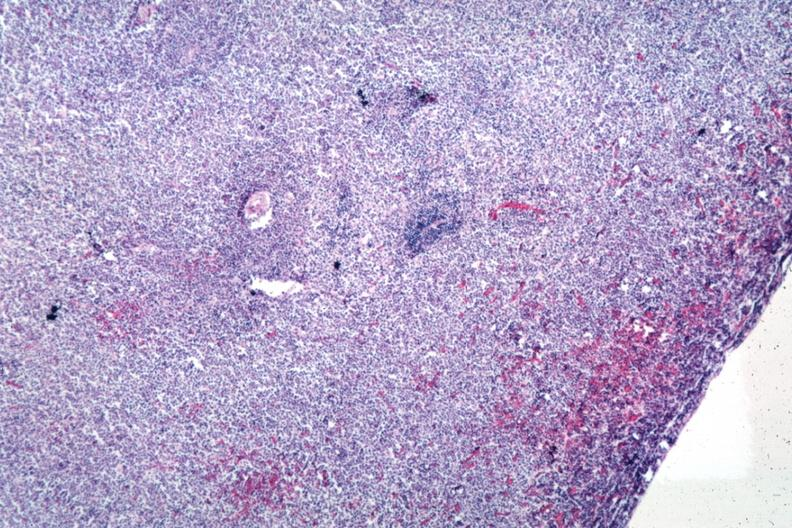what is present?
Answer the question using a single word or phrase. Hematologic 